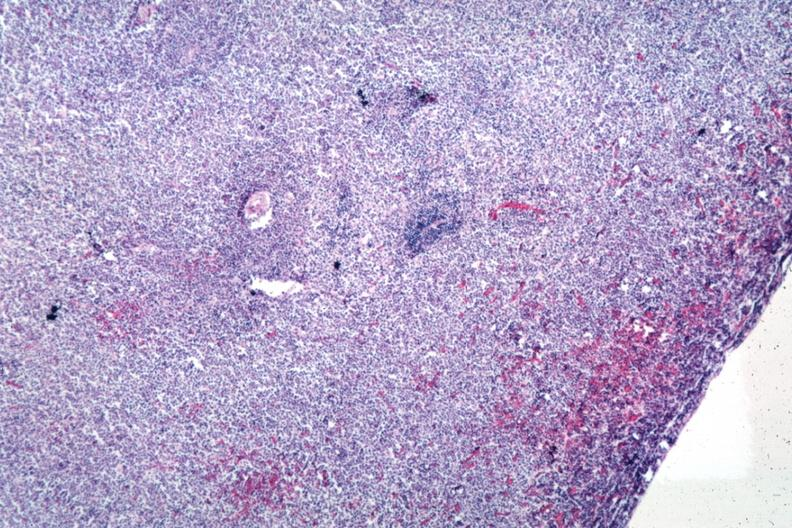what is present?
Answer the question using a single word or phrase. Hematologic 